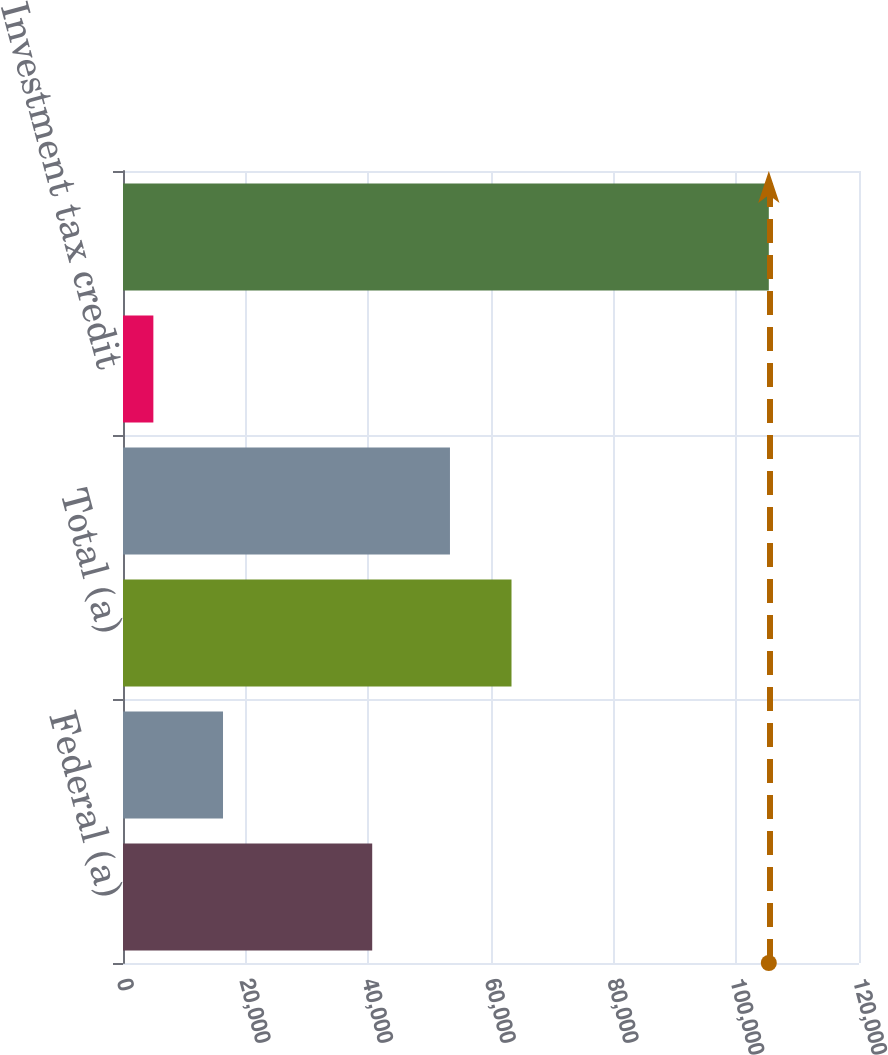Convert chart. <chart><loc_0><loc_0><loc_500><loc_500><bar_chart><fcel>Federal (a)<fcel>State (a)<fcel>Total (a)<fcel>Deferred -- net<fcel>Investment tax credit<fcel>Recorded income tax expense<nl><fcel>40632<fcel>16306<fcel>63343.5<fcel>53309<fcel>4951<fcel>105296<nl></chart> 